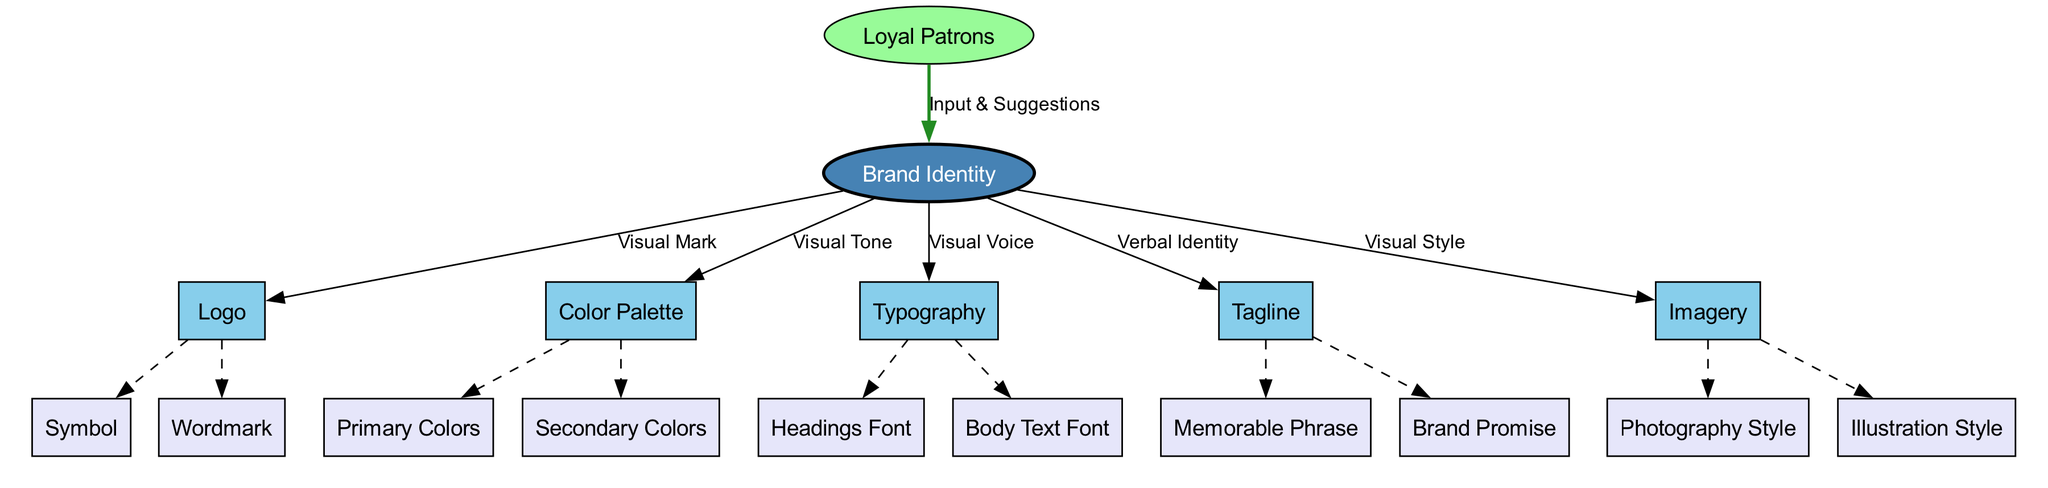What is the central node of the diagram? The central node is labeled "Brand Identity". This is the main concept around which the other elements are organized and connected in the diagram.
Answer: Brand Identity How many main elements are represented? The diagram consists of five main elements that branch out from the central node. They provide the core building blocks of the brand identity.
Answer: 5 What type of relationship does "Logo" have with "Brand Identity"? The relationship is described as "Visual Mark", indicating how the logo visually represents the brand. The connecting edge specifically labels this relationship.
Answer: Visual Mark What are the sub-elements of "Tagline"? The sub-elements of "Tagline" include "Memorable Phrase" and "Brand Promise", which are details that define the tagline's components. They are directly linked to the tagline in the diagram.
Answer: Memorable Phrase, Brand Promise Which element has a feedback input from "Loyal Patrons"? The "Brand Identity" element receives feedback labeled "Input & Suggestions" from the "Loyal Patrons". This indicates interaction and input that helps shape the brand.
Answer: Brand Identity Describe the visual tone of the brand according to the diagram. The visual tone is communicated through the "Color Palette", which represents the colors used in the brand identity, thus connecting to the overall aesthetic feel of the brand.
Answer: Color Palette Which two elements of brand identity have a connection through dashed lines in the diagram? The dashed lines connect the main elements to their respective sub-elements, showing that each main element can be further divided into detailed components, such as "Symbol" and "Wordmark" from "Logo".
Answer: Logo and Color Palette What is the visual style of the brand represented by in the diagram? The visual style is represented by the element labeled "Imagery", which includes the styles of photography and illustration that embody the brand's aesthetic.
Answer: Imagery How is "Typography" defined in relation to "Brand Identity"? "Typography" is defined as "Visual Voice", which implies it conveys the brand's character and message through its font choices, indicating how text should look in brand communications.
Answer: Visual Voice 